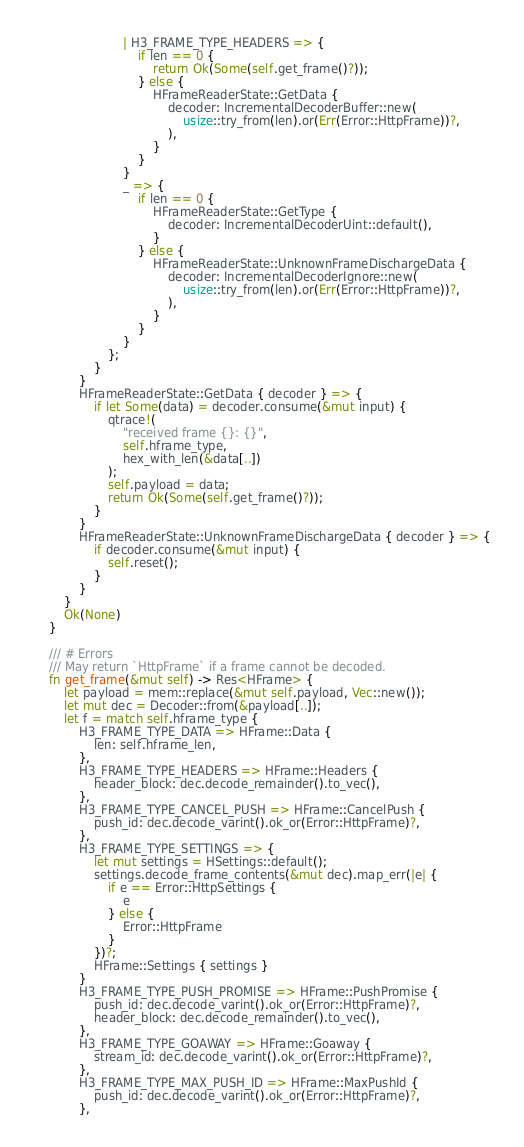<code> <loc_0><loc_0><loc_500><loc_500><_Rust_>                        | H3_FRAME_TYPE_HEADERS => {
                            if len == 0 {
                                return Ok(Some(self.get_frame()?));
                            } else {
                                HFrameReaderState::GetData {
                                    decoder: IncrementalDecoderBuffer::new(
                                        usize::try_from(len).or(Err(Error::HttpFrame))?,
                                    ),
                                }
                            }
                        }
                        _ => {
                            if len == 0 {
                                HFrameReaderState::GetType {
                                    decoder: IncrementalDecoderUint::default(),
                                }
                            } else {
                                HFrameReaderState::UnknownFrameDischargeData {
                                    decoder: IncrementalDecoderIgnore::new(
                                        usize::try_from(len).or(Err(Error::HttpFrame))?,
                                    ),
                                }
                            }
                        }
                    };
                }
            }
            HFrameReaderState::GetData { decoder } => {
                if let Some(data) = decoder.consume(&mut input) {
                    qtrace!(
                        "received frame {}: {}",
                        self.hframe_type,
                        hex_with_len(&data[..])
                    );
                    self.payload = data;
                    return Ok(Some(self.get_frame()?));
                }
            }
            HFrameReaderState::UnknownFrameDischargeData { decoder } => {
                if decoder.consume(&mut input) {
                    self.reset();
                }
            }
        }
        Ok(None)
    }

    /// # Errors
    /// May return `HttpFrame` if a frame cannot be decoded.
    fn get_frame(&mut self) -> Res<HFrame> {
        let payload = mem::replace(&mut self.payload, Vec::new());
        let mut dec = Decoder::from(&payload[..]);
        let f = match self.hframe_type {
            H3_FRAME_TYPE_DATA => HFrame::Data {
                len: self.hframe_len,
            },
            H3_FRAME_TYPE_HEADERS => HFrame::Headers {
                header_block: dec.decode_remainder().to_vec(),
            },
            H3_FRAME_TYPE_CANCEL_PUSH => HFrame::CancelPush {
                push_id: dec.decode_varint().ok_or(Error::HttpFrame)?,
            },
            H3_FRAME_TYPE_SETTINGS => {
                let mut settings = HSettings::default();
                settings.decode_frame_contents(&mut dec).map_err(|e| {
                    if e == Error::HttpSettings {
                        e
                    } else {
                        Error::HttpFrame
                    }
                })?;
                HFrame::Settings { settings }
            }
            H3_FRAME_TYPE_PUSH_PROMISE => HFrame::PushPromise {
                push_id: dec.decode_varint().ok_or(Error::HttpFrame)?,
                header_block: dec.decode_remainder().to_vec(),
            },
            H3_FRAME_TYPE_GOAWAY => HFrame::Goaway {
                stream_id: dec.decode_varint().ok_or(Error::HttpFrame)?,
            },
            H3_FRAME_TYPE_MAX_PUSH_ID => HFrame::MaxPushId {
                push_id: dec.decode_varint().ok_or(Error::HttpFrame)?,
            },</code> 